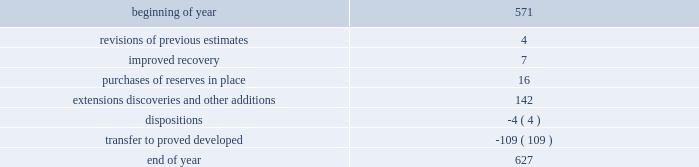Changes in proved undeveloped reserves as of december 31 , 2013 , 627 mmboe of proved undeveloped reserves were reported , an increase of 56 mmboe from december 31 , 2012 .
The table shows changes in total proved undeveloped reserves for 2013 : ( mmboe ) .
Significant additions to proved undeveloped reserves during 2013 included 72 mmboe in the eagle ford and 49 mmboe in the bakken shale plays due to development drilling .
Transfers from proved undeveloped to proved developed reserves included 57 mmboe in the eagle ford , 18 mmboe in the bakken and 7 mmboe in the oklahoma resource basins due to producing wells .
Costs incurred in 2013 , 2012 and 2011 relating to the development of proved undeveloped reserves , were $ 2536 million , $ 1995 million and $ 1107 million .
A total of 59 mmboe was booked as a result of reliable technology .
Technologies included statistical analysis of production performance , decline curve analysis , rate transient analysis , reservoir simulation and volumetric analysis .
The statistical nature of production performance coupled with highly certain reservoir continuity or quality within the reliable technology areas and sufficient proved undeveloped locations establish the reasonable certainty criteria required for booking reserves .
Projects can remain in proved undeveloped reserves for extended periods in certain situations such as large development projects which take more than five years to complete , or the timing of when additional gas compression is needed .
Of the 627 mmboe of proved undeveloped reserves at december 31 , 2013 , 24 percent of the volume is associated with projects that have been included in proved reserves for more than five years .
The majority of this volume is related to a compression project in e.g .
That was sanctioned by our board of directors in 2004 .
The timing of the installation of compression is being driven by the reservoir performance with this project intended to maintain maximum production levels .
Performance of this field since the board sanctioned the project has far exceeded expectations .
Estimates of initial dry gas in place increased by roughly 10 percent between 2004 and 2010 .
During 2012 , the compression project received the approval of the e.g .
Government , allowing design and planning work to progress towards implementation , with completion expected by mid-2016 .
The other component of alba proved undeveloped reserves is an infill well approved in 2013 and to be drilled late 2014 .
Proved undeveloped reserves for the north gialo development , located in the libyan sahara desert , were booked for the first time as proved undeveloped reserves in 2010 .
This development , which is anticipated to take more than five years to be developed , is being executed by the operator and encompasses a continuous drilling program including the design , fabrication and installation of extensive liquid handling and gas recycling facilities .
Anecdotal evidence from similar development projects in the region led to an expected project execution of more than five years from the time the reserves were initially booked .
Interruptions associated with the civil unrest in 2011 and third-party labor strikes in 2013 have extended the project duration .
There are no other significant undeveloped reserves expected to be developed more than five years after their original booking .
As of december 31 , 2013 , future development costs estimated to be required for the development of proved undeveloped liquid hydrocarbon , natural gas and synthetic crude oil reserves related to continuing operations for the years 2014 through 2018 are projected to be $ 2894 million , $ 2567 million , $ 2020 million , $ 1452 million and $ 575 million .
The timing of future projects and estimated future development costs relating to the development of proved undeveloped liquid hydrocarbon , natural gas and synthetic crude oil reserves are forward-looking statements and are based on a number of assumptions , including ( among others ) commodity prices , presently known physical data concerning size and character of the reservoirs , economic recoverability , technology developments , future drilling success , industry economic conditions , levels of cash flow from operations , production experience and other operating considerations .
To the extent these assumptions prove inaccurate , actual recoveries , timing and development costs could be different than current estimates. .
By how much did total proved undeveloped reserves increase during 2013? 
Computations: (56 / 571)
Answer: 0.09807. 